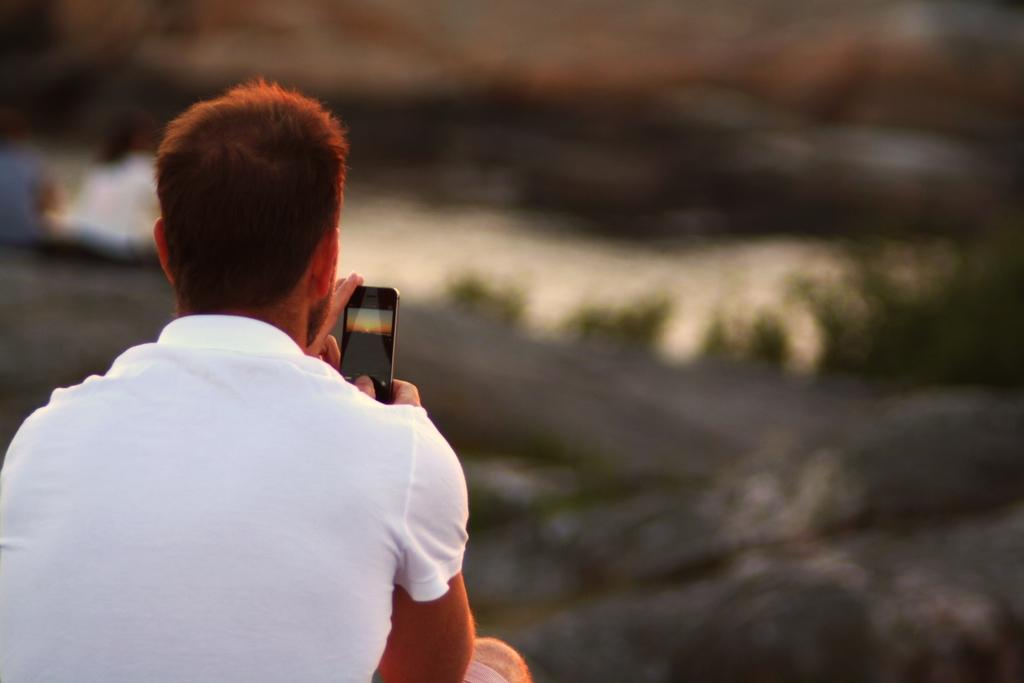Who is present in the image? There is a man in the image. What is the man holding in his hand? The man is holding a phone in his hand. Can you describe the background of the image? The background of the image is blurry. What type of brake can be seen on the man's shoes in the image? There are no shoes or brakes visible in the image; the man is holding a phone in his hand. 